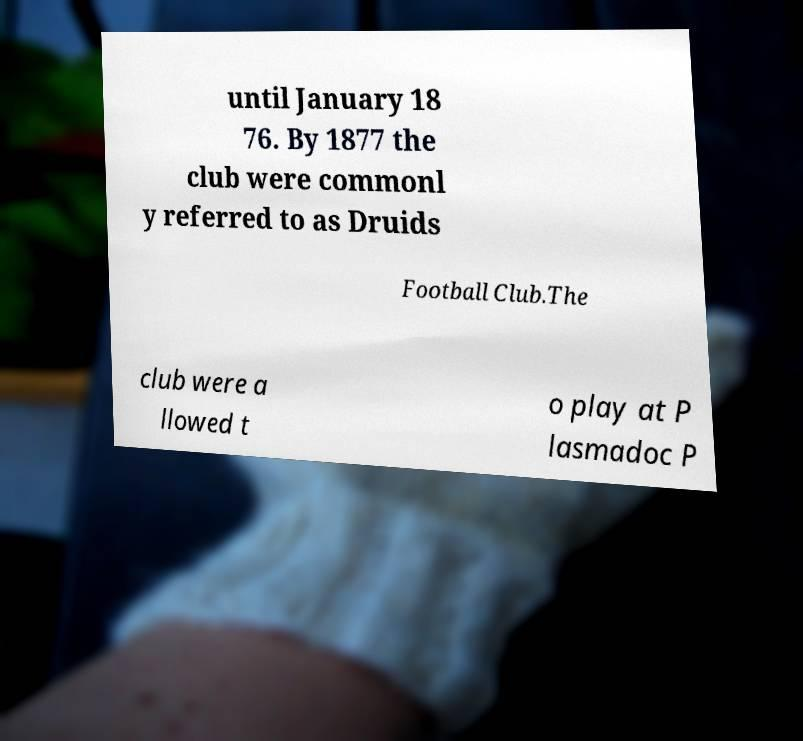Can you accurately transcribe the text from the provided image for me? until January 18 76. By 1877 the club were commonl y referred to as Druids Football Club.The club were a llowed t o play at P lasmadoc P 